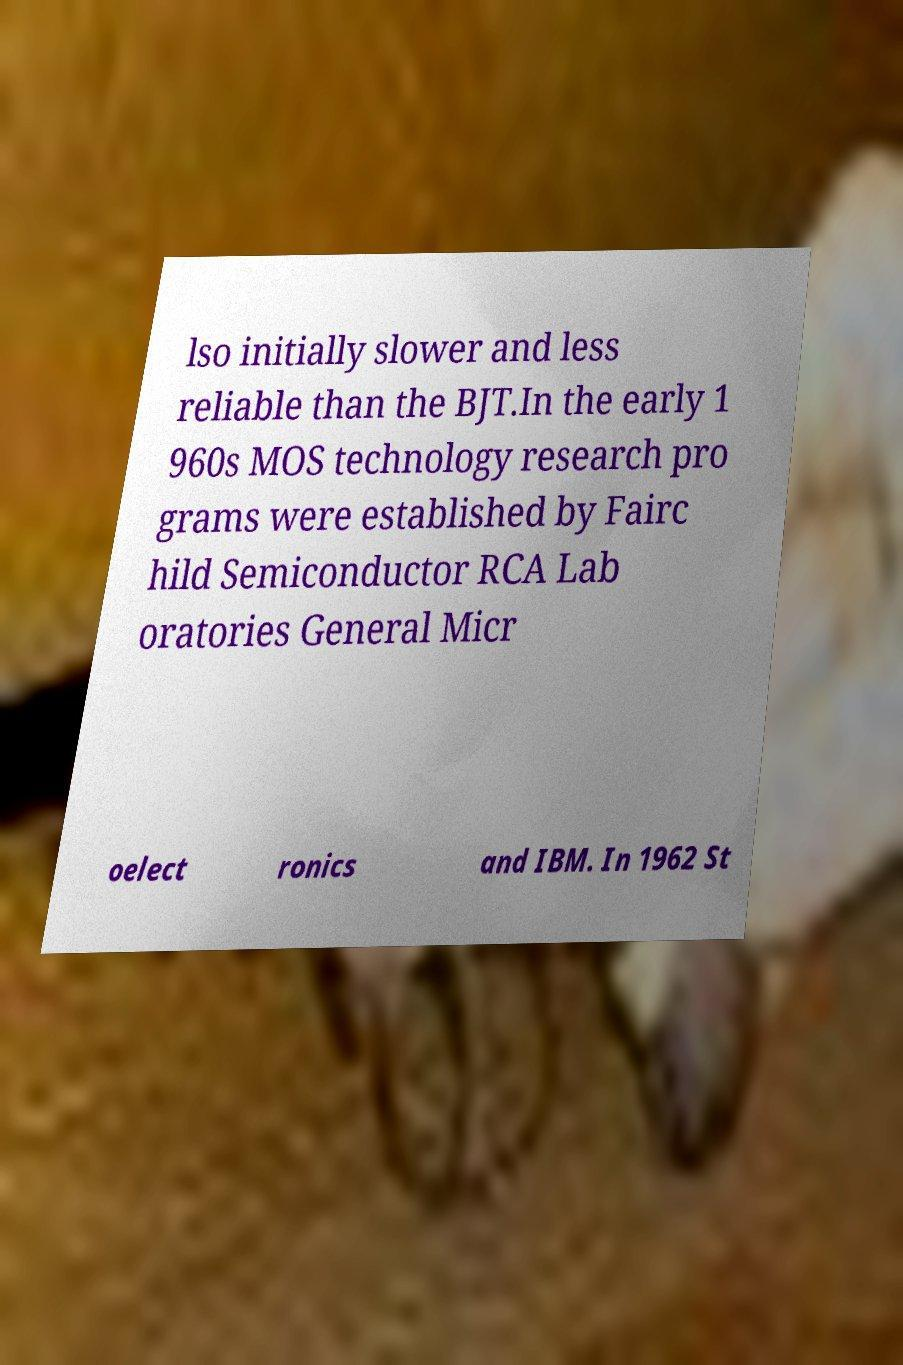Please read and relay the text visible in this image. What does it say? lso initially slower and less reliable than the BJT.In the early 1 960s MOS technology research pro grams were established by Fairc hild Semiconductor RCA Lab oratories General Micr oelect ronics and IBM. In 1962 St 